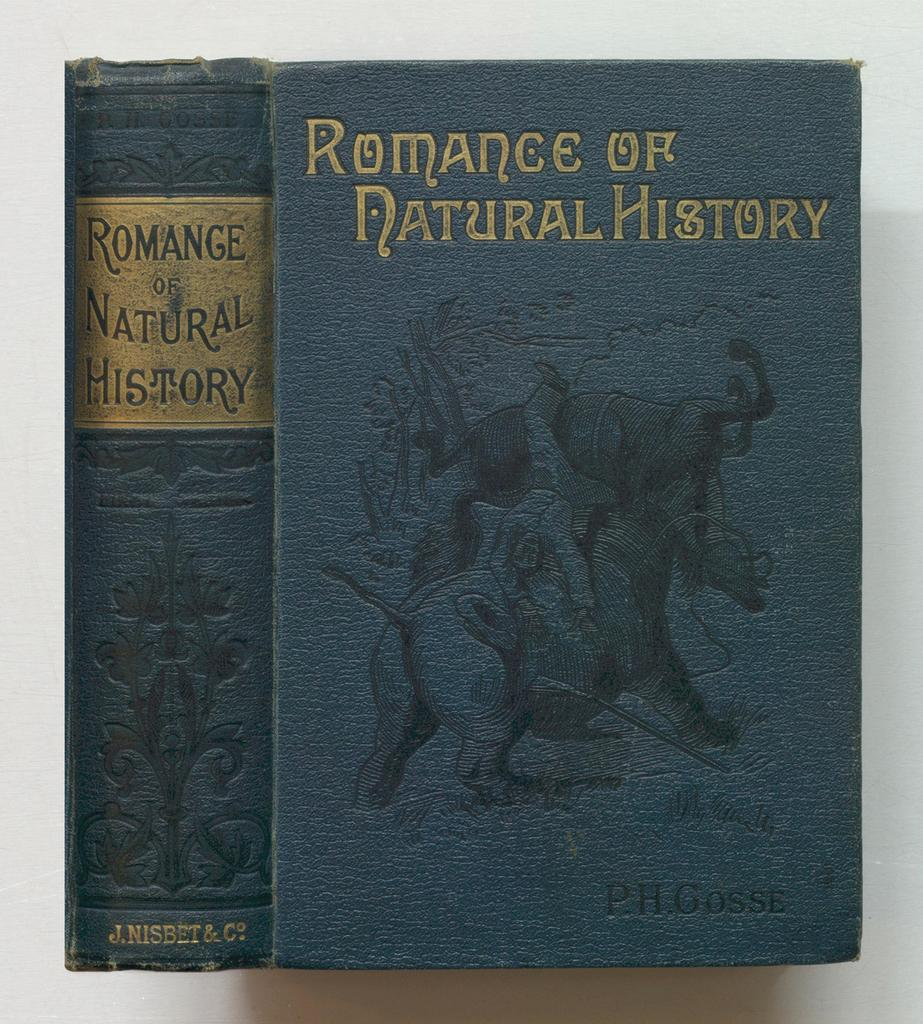<image>
Summarize the visual content of the image. A book titled Romance of Natural History by PH Gosse 